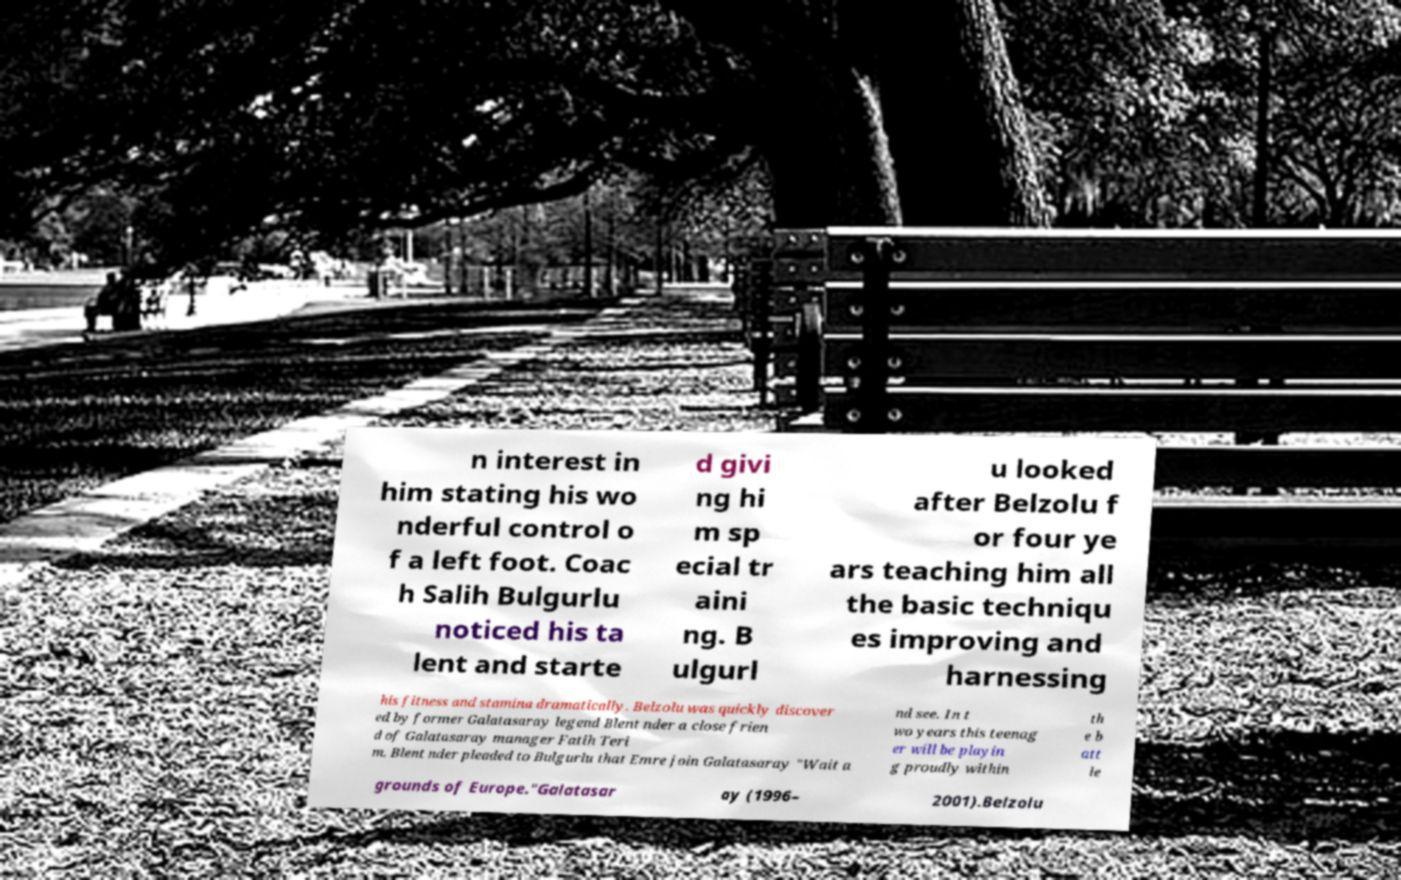There's text embedded in this image that I need extracted. Can you transcribe it verbatim? n interest in him stating his wo nderful control o f a left foot. Coac h Salih Bulgurlu noticed his ta lent and starte d givi ng hi m sp ecial tr aini ng. B ulgurl u looked after Belzolu f or four ye ars teaching him all the basic techniqu es improving and harnessing his fitness and stamina dramatically. Belzolu was quickly discover ed by former Galatasaray legend Blent nder a close frien d of Galatasaray manager Fatih Teri m. Blent nder pleaded to Bulgurlu that Emre join Galatasaray "Wait a nd see. In t wo years this teenag er will be playin g proudly within th e b att le grounds of Europe."Galatasar ay (1996– 2001).Belzolu 